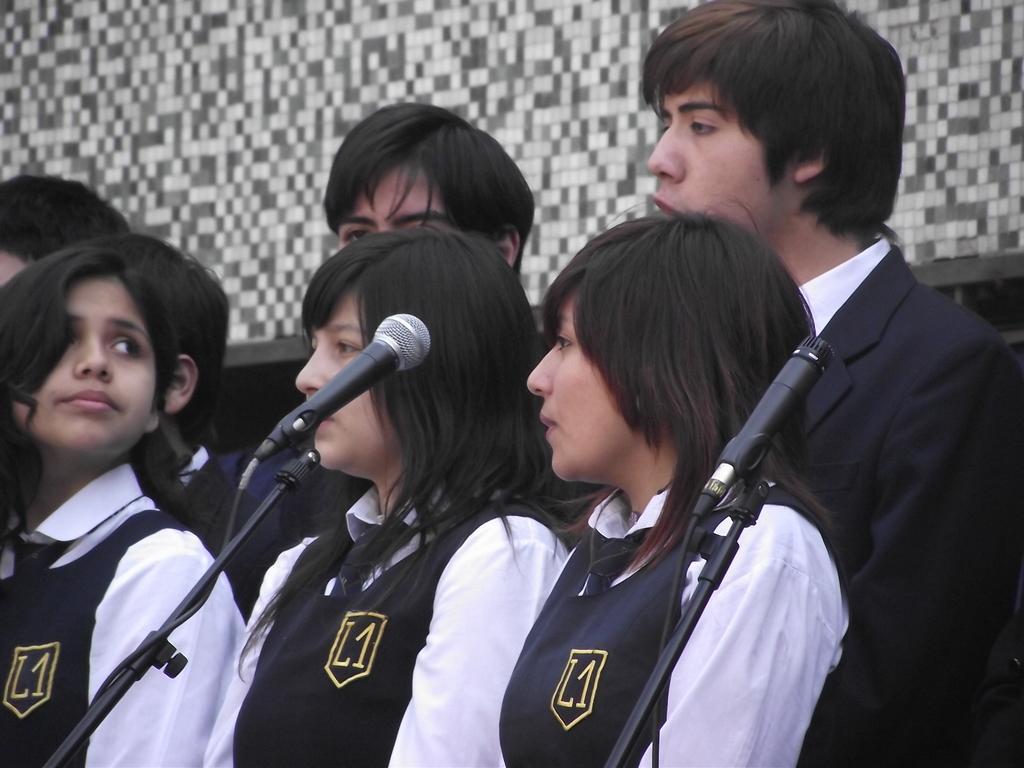Can you describe this image briefly? In this picture we can see few persons and there are mike's. In the background there is a wall. 